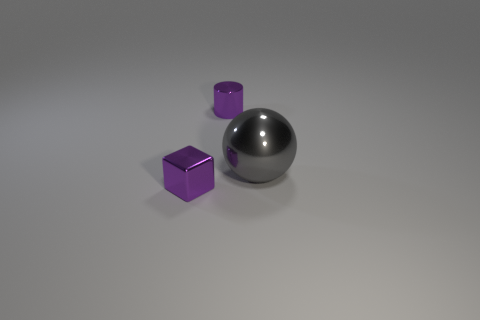There is a purple shiny thing behind the shiny cube; is its shape the same as the thing in front of the big gray thing?
Keep it short and to the point. No. What size is the cylinder that is behind the big thing?
Ensure brevity in your answer.  Small. How big is the purple shiny object on the left side of the purple metallic cylinder right of the purple metal cube?
Your answer should be very brief. Small. Are there more things than tiny metal blocks?
Provide a short and direct response. Yes. Is the number of cylinders in front of the tiny purple metallic block greater than the number of purple metal things on the left side of the tiny cylinder?
Provide a succinct answer. No. There is a shiny thing that is left of the large gray thing and to the right of the metal block; how big is it?
Provide a short and direct response. Small. What number of purple objects have the same size as the purple block?
Offer a very short reply. 1. There is a tiny object that is the same color as the tiny block; what material is it?
Offer a terse response. Metal. There is a purple object that is to the left of the shiny cylinder; is its shape the same as the big gray object?
Provide a succinct answer. No. Are there fewer tiny purple metallic blocks that are to the right of the large gray sphere than large shiny objects?
Your answer should be compact. Yes. 